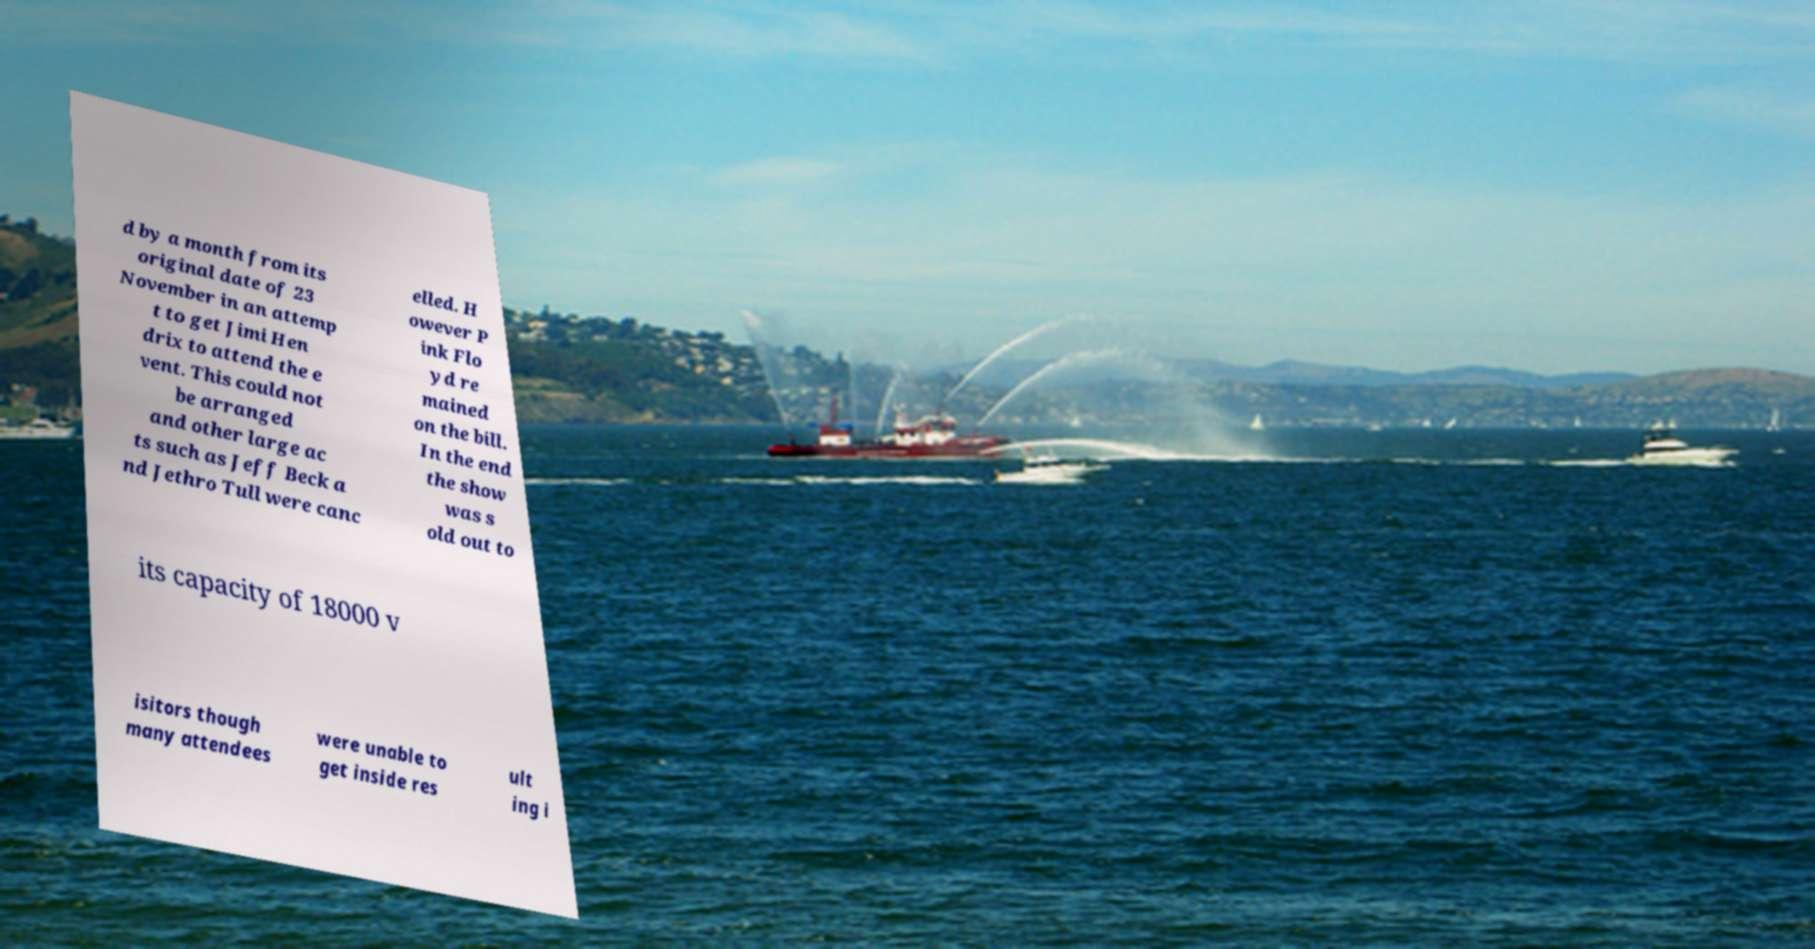Could you assist in decoding the text presented in this image and type it out clearly? d by a month from its original date of 23 November in an attemp t to get Jimi Hen drix to attend the e vent. This could not be arranged and other large ac ts such as Jeff Beck a nd Jethro Tull were canc elled. H owever P ink Flo yd re mained on the bill. In the end the show was s old out to its capacity of 18000 v isitors though many attendees were unable to get inside res ult ing i 